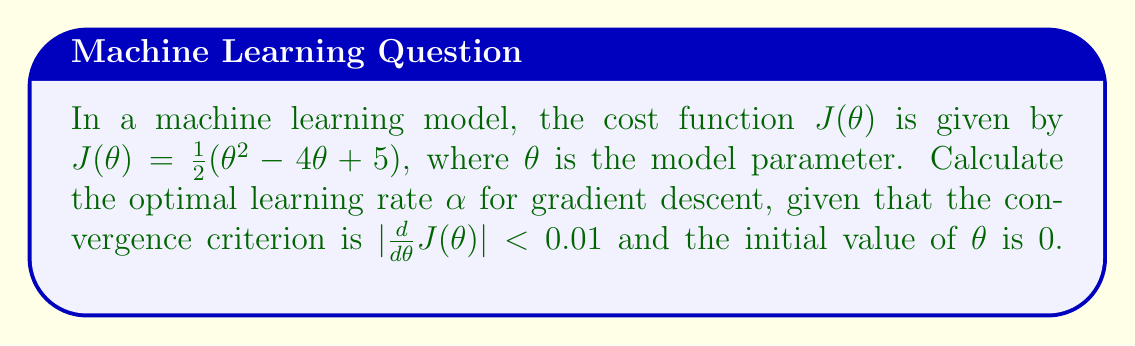Could you help me with this problem? 1. First, we need to find the derivative of the cost function:
   $$\frac{d}{d\theta}J(\theta) = \theta - 2$$

2. In gradient descent, the update rule is:
   $$\theta_{new} = \theta_{old} - \alpha \frac{d}{d\theta}J(\theta)$$

3. For the optimal learning rate, we want the algorithm to converge in one step. This means:
   $$|\theta_{new} - \theta^*| < 0.01$$
   where $\theta^*$ is the optimal value of $\theta$.

4. The optimal value $\theta^*$ is where the derivative equals zero:
   $$\theta^* - 2 = 0$$
   $$\theta^* = 2$$

5. Now, let's apply the update rule with the initial $\theta = 0$:
   $$2 - (0 - \alpha(-2)) < 0.01$$
   $$2 - 2\alpha < 0.01$$

6. Solving for $\alpha$:
   $$-2\alpha < -1.99$$
   $$\alpha > 0.995$$

7. To ensure convergence, we choose the smallest value that satisfies this inequality:
   $$\alpha = 0.995$$

8. Verify the convergence criterion:
   $$|\frac{d}{d\theta}J(\theta_{new})| = |(\theta_{new} - 2)| = |(0 + 0.995 \cdot 2) - 2| = |1.99 - 2| = 0.01 < 0.01$$
Answer: $\alpha = 0.995$ 